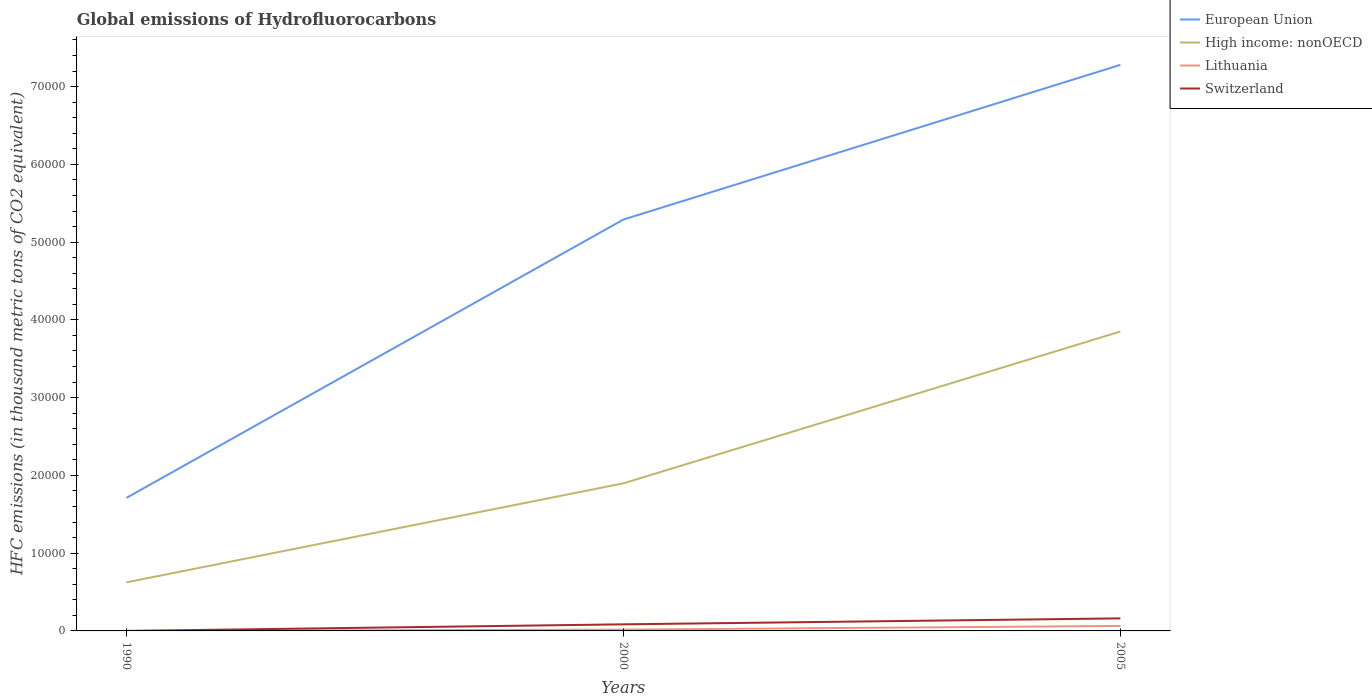How many different coloured lines are there?
Provide a succinct answer. 4. Is the number of lines equal to the number of legend labels?
Your response must be concise. Yes. Across all years, what is the maximum global emissions of Hydrofluorocarbons in European Union?
Offer a very short reply. 1.71e+04. What is the total global emissions of Hydrofluorocarbons in Switzerland in the graph?
Provide a short and direct response. -847.9. What is the difference between the highest and the second highest global emissions of Hydrofluorocarbons in Switzerland?
Keep it short and to the point. 1613.5. What is the difference between the highest and the lowest global emissions of Hydrofluorocarbons in Switzerland?
Ensure brevity in your answer.  2. Is the global emissions of Hydrofluorocarbons in Lithuania strictly greater than the global emissions of Hydrofluorocarbons in High income: nonOECD over the years?
Provide a succinct answer. Yes. How many lines are there?
Provide a succinct answer. 4. What is the difference between two consecutive major ticks on the Y-axis?
Keep it short and to the point. 10000. Does the graph contain grids?
Offer a terse response. No. How are the legend labels stacked?
Make the answer very short. Vertical. What is the title of the graph?
Provide a short and direct response. Global emissions of Hydrofluorocarbons. What is the label or title of the Y-axis?
Your answer should be compact. HFC emissions (in thousand metric tons of CO2 equivalent). What is the HFC emissions (in thousand metric tons of CO2 equivalent) of European Union in 1990?
Provide a succinct answer. 1.71e+04. What is the HFC emissions (in thousand metric tons of CO2 equivalent) in High income: nonOECD in 1990?
Your answer should be compact. 6246.3. What is the HFC emissions (in thousand metric tons of CO2 equivalent) in Lithuania in 1990?
Offer a very short reply. 0.1. What is the HFC emissions (in thousand metric tons of CO2 equivalent) of European Union in 2000?
Ensure brevity in your answer.  5.29e+04. What is the HFC emissions (in thousand metric tons of CO2 equivalent) of High income: nonOECD in 2000?
Keep it short and to the point. 1.90e+04. What is the HFC emissions (in thousand metric tons of CO2 equivalent) of Lithuania in 2000?
Your response must be concise. 164.5. What is the HFC emissions (in thousand metric tons of CO2 equivalent) in Switzerland in 2000?
Your response must be concise. 848.2. What is the HFC emissions (in thousand metric tons of CO2 equivalent) in European Union in 2005?
Your answer should be very brief. 7.28e+04. What is the HFC emissions (in thousand metric tons of CO2 equivalent) of High income: nonOECD in 2005?
Your answer should be compact. 3.85e+04. What is the HFC emissions (in thousand metric tons of CO2 equivalent) in Lithuania in 2005?
Make the answer very short. 642.1. What is the HFC emissions (in thousand metric tons of CO2 equivalent) in Switzerland in 2005?
Make the answer very short. 1613.8. Across all years, what is the maximum HFC emissions (in thousand metric tons of CO2 equivalent) in European Union?
Offer a terse response. 7.28e+04. Across all years, what is the maximum HFC emissions (in thousand metric tons of CO2 equivalent) of High income: nonOECD?
Make the answer very short. 3.85e+04. Across all years, what is the maximum HFC emissions (in thousand metric tons of CO2 equivalent) in Lithuania?
Give a very brief answer. 642.1. Across all years, what is the maximum HFC emissions (in thousand metric tons of CO2 equivalent) of Switzerland?
Make the answer very short. 1613.8. Across all years, what is the minimum HFC emissions (in thousand metric tons of CO2 equivalent) in European Union?
Your answer should be compact. 1.71e+04. Across all years, what is the minimum HFC emissions (in thousand metric tons of CO2 equivalent) of High income: nonOECD?
Offer a very short reply. 6246.3. Across all years, what is the minimum HFC emissions (in thousand metric tons of CO2 equivalent) in Lithuania?
Offer a terse response. 0.1. What is the total HFC emissions (in thousand metric tons of CO2 equivalent) in European Union in the graph?
Keep it short and to the point. 1.43e+05. What is the total HFC emissions (in thousand metric tons of CO2 equivalent) of High income: nonOECD in the graph?
Make the answer very short. 6.37e+04. What is the total HFC emissions (in thousand metric tons of CO2 equivalent) in Lithuania in the graph?
Offer a very short reply. 806.7. What is the total HFC emissions (in thousand metric tons of CO2 equivalent) of Switzerland in the graph?
Ensure brevity in your answer.  2462.3. What is the difference between the HFC emissions (in thousand metric tons of CO2 equivalent) in European Union in 1990 and that in 2000?
Your response must be concise. -3.58e+04. What is the difference between the HFC emissions (in thousand metric tons of CO2 equivalent) of High income: nonOECD in 1990 and that in 2000?
Offer a terse response. -1.27e+04. What is the difference between the HFC emissions (in thousand metric tons of CO2 equivalent) of Lithuania in 1990 and that in 2000?
Make the answer very short. -164.4. What is the difference between the HFC emissions (in thousand metric tons of CO2 equivalent) of Switzerland in 1990 and that in 2000?
Provide a succinct answer. -847.9. What is the difference between the HFC emissions (in thousand metric tons of CO2 equivalent) of European Union in 1990 and that in 2005?
Your answer should be compact. -5.57e+04. What is the difference between the HFC emissions (in thousand metric tons of CO2 equivalent) of High income: nonOECD in 1990 and that in 2005?
Keep it short and to the point. -3.23e+04. What is the difference between the HFC emissions (in thousand metric tons of CO2 equivalent) of Lithuania in 1990 and that in 2005?
Your response must be concise. -642. What is the difference between the HFC emissions (in thousand metric tons of CO2 equivalent) of Switzerland in 1990 and that in 2005?
Make the answer very short. -1613.5. What is the difference between the HFC emissions (in thousand metric tons of CO2 equivalent) in European Union in 2000 and that in 2005?
Provide a succinct answer. -1.99e+04. What is the difference between the HFC emissions (in thousand metric tons of CO2 equivalent) of High income: nonOECD in 2000 and that in 2005?
Offer a very short reply. -1.95e+04. What is the difference between the HFC emissions (in thousand metric tons of CO2 equivalent) in Lithuania in 2000 and that in 2005?
Provide a short and direct response. -477.6. What is the difference between the HFC emissions (in thousand metric tons of CO2 equivalent) of Switzerland in 2000 and that in 2005?
Your answer should be very brief. -765.6. What is the difference between the HFC emissions (in thousand metric tons of CO2 equivalent) of European Union in 1990 and the HFC emissions (in thousand metric tons of CO2 equivalent) of High income: nonOECD in 2000?
Ensure brevity in your answer.  -1868.6. What is the difference between the HFC emissions (in thousand metric tons of CO2 equivalent) in European Union in 1990 and the HFC emissions (in thousand metric tons of CO2 equivalent) in Lithuania in 2000?
Give a very brief answer. 1.69e+04. What is the difference between the HFC emissions (in thousand metric tons of CO2 equivalent) in European Union in 1990 and the HFC emissions (in thousand metric tons of CO2 equivalent) in Switzerland in 2000?
Offer a very short reply. 1.63e+04. What is the difference between the HFC emissions (in thousand metric tons of CO2 equivalent) of High income: nonOECD in 1990 and the HFC emissions (in thousand metric tons of CO2 equivalent) of Lithuania in 2000?
Ensure brevity in your answer.  6081.8. What is the difference between the HFC emissions (in thousand metric tons of CO2 equivalent) of High income: nonOECD in 1990 and the HFC emissions (in thousand metric tons of CO2 equivalent) of Switzerland in 2000?
Make the answer very short. 5398.1. What is the difference between the HFC emissions (in thousand metric tons of CO2 equivalent) of Lithuania in 1990 and the HFC emissions (in thousand metric tons of CO2 equivalent) of Switzerland in 2000?
Provide a succinct answer. -848.1. What is the difference between the HFC emissions (in thousand metric tons of CO2 equivalent) of European Union in 1990 and the HFC emissions (in thousand metric tons of CO2 equivalent) of High income: nonOECD in 2005?
Your response must be concise. -2.14e+04. What is the difference between the HFC emissions (in thousand metric tons of CO2 equivalent) in European Union in 1990 and the HFC emissions (in thousand metric tons of CO2 equivalent) in Lithuania in 2005?
Your response must be concise. 1.65e+04. What is the difference between the HFC emissions (in thousand metric tons of CO2 equivalent) of European Union in 1990 and the HFC emissions (in thousand metric tons of CO2 equivalent) of Switzerland in 2005?
Offer a terse response. 1.55e+04. What is the difference between the HFC emissions (in thousand metric tons of CO2 equivalent) of High income: nonOECD in 1990 and the HFC emissions (in thousand metric tons of CO2 equivalent) of Lithuania in 2005?
Keep it short and to the point. 5604.2. What is the difference between the HFC emissions (in thousand metric tons of CO2 equivalent) of High income: nonOECD in 1990 and the HFC emissions (in thousand metric tons of CO2 equivalent) of Switzerland in 2005?
Make the answer very short. 4632.5. What is the difference between the HFC emissions (in thousand metric tons of CO2 equivalent) of Lithuania in 1990 and the HFC emissions (in thousand metric tons of CO2 equivalent) of Switzerland in 2005?
Keep it short and to the point. -1613.7. What is the difference between the HFC emissions (in thousand metric tons of CO2 equivalent) of European Union in 2000 and the HFC emissions (in thousand metric tons of CO2 equivalent) of High income: nonOECD in 2005?
Make the answer very short. 1.44e+04. What is the difference between the HFC emissions (in thousand metric tons of CO2 equivalent) in European Union in 2000 and the HFC emissions (in thousand metric tons of CO2 equivalent) in Lithuania in 2005?
Offer a very short reply. 5.23e+04. What is the difference between the HFC emissions (in thousand metric tons of CO2 equivalent) in European Union in 2000 and the HFC emissions (in thousand metric tons of CO2 equivalent) in Switzerland in 2005?
Offer a very short reply. 5.13e+04. What is the difference between the HFC emissions (in thousand metric tons of CO2 equivalent) of High income: nonOECD in 2000 and the HFC emissions (in thousand metric tons of CO2 equivalent) of Lithuania in 2005?
Keep it short and to the point. 1.83e+04. What is the difference between the HFC emissions (in thousand metric tons of CO2 equivalent) of High income: nonOECD in 2000 and the HFC emissions (in thousand metric tons of CO2 equivalent) of Switzerland in 2005?
Offer a terse response. 1.74e+04. What is the difference between the HFC emissions (in thousand metric tons of CO2 equivalent) of Lithuania in 2000 and the HFC emissions (in thousand metric tons of CO2 equivalent) of Switzerland in 2005?
Keep it short and to the point. -1449.3. What is the average HFC emissions (in thousand metric tons of CO2 equivalent) of European Union per year?
Your answer should be very brief. 4.76e+04. What is the average HFC emissions (in thousand metric tons of CO2 equivalent) in High income: nonOECD per year?
Your response must be concise. 2.12e+04. What is the average HFC emissions (in thousand metric tons of CO2 equivalent) in Lithuania per year?
Your answer should be compact. 268.9. What is the average HFC emissions (in thousand metric tons of CO2 equivalent) in Switzerland per year?
Your answer should be very brief. 820.77. In the year 1990, what is the difference between the HFC emissions (in thousand metric tons of CO2 equivalent) of European Union and HFC emissions (in thousand metric tons of CO2 equivalent) of High income: nonOECD?
Offer a terse response. 1.09e+04. In the year 1990, what is the difference between the HFC emissions (in thousand metric tons of CO2 equivalent) of European Union and HFC emissions (in thousand metric tons of CO2 equivalent) of Lithuania?
Offer a terse response. 1.71e+04. In the year 1990, what is the difference between the HFC emissions (in thousand metric tons of CO2 equivalent) in European Union and HFC emissions (in thousand metric tons of CO2 equivalent) in Switzerland?
Offer a very short reply. 1.71e+04. In the year 1990, what is the difference between the HFC emissions (in thousand metric tons of CO2 equivalent) of High income: nonOECD and HFC emissions (in thousand metric tons of CO2 equivalent) of Lithuania?
Provide a short and direct response. 6246.2. In the year 1990, what is the difference between the HFC emissions (in thousand metric tons of CO2 equivalent) in High income: nonOECD and HFC emissions (in thousand metric tons of CO2 equivalent) in Switzerland?
Your response must be concise. 6246. In the year 2000, what is the difference between the HFC emissions (in thousand metric tons of CO2 equivalent) in European Union and HFC emissions (in thousand metric tons of CO2 equivalent) in High income: nonOECD?
Make the answer very short. 3.39e+04. In the year 2000, what is the difference between the HFC emissions (in thousand metric tons of CO2 equivalent) in European Union and HFC emissions (in thousand metric tons of CO2 equivalent) in Lithuania?
Provide a short and direct response. 5.27e+04. In the year 2000, what is the difference between the HFC emissions (in thousand metric tons of CO2 equivalent) in European Union and HFC emissions (in thousand metric tons of CO2 equivalent) in Switzerland?
Keep it short and to the point. 5.21e+04. In the year 2000, what is the difference between the HFC emissions (in thousand metric tons of CO2 equivalent) in High income: nonOECD and HFC emissions (in thousand metric tons of CO2 equivalent) in Lithuania?
Give a very brief answer. 1.88e+04. In the year 2000, what is the difference between the HFC emissions (in thousand metric tons of CO2 equivalent) in High income: nonOECD and HFC emissions (in thousand metric tons of CO2 equivalent) in Switzerland?
Make the answer very short. 1.81e+04. In the year 2000, what is the difference between the HFC emissions (in thousand metric tons of CO2 equivalent) in Lithuania and HFC emissions (in thousand metric tons of CO2 equivalent) in Switzerland?
Give a very brief answer. -683.7. In the year 2005, what is the difference between the HFC emissions (in thousand metric tons of CO2 equivalent) of European Union and HFC emissions (in thousand metric tons of CO2 equivalent) of High income: nonOECD?
Your answer should be very brief. 3.43e+04. In the year 2005, what is the difference between the HFC emissions (in thousand metric tons of CO2 equivalent) in European Union and HFC emissions (in thousand metric tons of CO2 equivalent) in Lithuania?
Keep it short and to the point. 7.21e+04. In the year 2005, what is the difference between the HFC emissions (in thousand metric tons of CO2 equivalent) in European Union and HFC emissions (in thousand metric tons of CO2 equivalent) in Switzerland?
Offer a very short reply. 7.12e+04. In the year 2005, what is the difference between the HFC emissions (in thousand metric tons of CO2 equivalent) of High income: nonOECD and HFC emissions (in thousand metric tons of CO2 equivalent) of Lithuania?
Offer a terse response. 3.79e+04. In the year 2005, what is the difference between the HFC emissions (in thousand metric tons of CO2 equivalent) in High income: nonOECD and HFC emissions (in thousand metric tons of CO2 equivalent) in Switzerland?
Provide a succinct answer. 3.69e+04. In the year 2005, what is the difference between the HFC emissions (in thousand metric tons of CO2 equivalent) in Lithuania and HFC emissions (in thousand metric tons of CO2 equivalent) in Switzerland?
Ensure brevity in your answer.  -971.7. What is the ratio of the HFC emissions (in thousand metric tons of CO2 equivalent) in European Union in 1990 to that in 2000?
Your answer should be compact. 0.32. What is the ratio of the HFC emissions (in thousand metric tons of CO2 equivalent) of High income: nonOECD in 1990 to that in 2000?
Provide a short and direct response. 0.33. What is the ratio of the HFC emissions (in thousand metric tons of CO2 equivalent) in Lithuania in 1990 to that in 2000?
Ensure brevity in your answer.  0. What is the ratio of the HFC emissions (in thousand metric tons of CO2 equivalent) of European Union in 1990 to that in 2005?
Your response must be concise. 0.24. What is the ratio of the HFC emissions (in thousand metric tons of CO2 equivalent) in High income: nonOECD in 1990 to that in 2005?
Ensure brevity in your answer.  0.16. What is the ratio of the HFC emissions (in thousand metric tons of CO2 equivalent) in Lithuania in 1990 to that in 2005?
Provide a short and direct response. 0. What is the ratio of the HFC emissions (in thousand metric tons of CO2 equivalent) in Switzerland in 1990 to that in 2005?
Keep it short and to the point. 0. What is the ratio of the HFC emissions (in thousand metric tons of CO2 equivalent) in European Union in 2000 to that in 2005?
Provide a succinct answer. 0.73. What is the ratio of the HFC emissions (in thousand metric tons of CO2 equivalent) in High income: nonOECD in 2000 to that in 2005?
Make the answer very short. 0.49. What is the ratio of the HFC emissions (in thousand metric tons of CO2 equivalent) of Lithuania in 2000 to that in 2005?
Offer a terse response. 0.26. What is the ratio of the HFC emissions (in thousand metric tons of CO2 equivalent) of Switzerland in 2000 to that in 2005?
Your answer should be compact. 0.53. What is the difference between the highest and the second highest HFC emissions (in thousand metric tons of CO2 equivalent) of European Union?
Offer a very short reply. 1.99e+04. What is the difference between the highest and the second highest HFC emissions (in thousand metric tons of CO2 equivalent) of High income: nonOECD?
Your answer should be very brief. 1.95e+04. What is the difference between the highest and the second highest HFC emissions (in thousand metric tons of CO2 equivalent) in Lithuania?
Provide a short and direct response. 477.6. What is the difference between the highest and the second highest HFC emissions (in thousand metric tons of CO2 equivalent) of Switzerland?
Provide a short and direct response. 765.6. What is the difference between the highest and the lowest HFC emissions (in thousand metric tons of CO2 equivalent) of European Union?
Offer a very short reply. 5.57e+04. What is the difference between the highest and the lowest HFC emissions (in thousand metric tons of CO2 equivalent) of High income: nonOECD?
Make the answer very short. 3.23e+04. What is the difference between the highest and the lowest HFC emissions (in thousand metric tons of CO2 equivalent) of Lithuania?
Make the answer very short. 642. What is the difference between the highest and the lowest HFC emissions (in thousand metric tons of CO2 equivalent) in Switzerland?
Make the answer very short. 1613.5. 